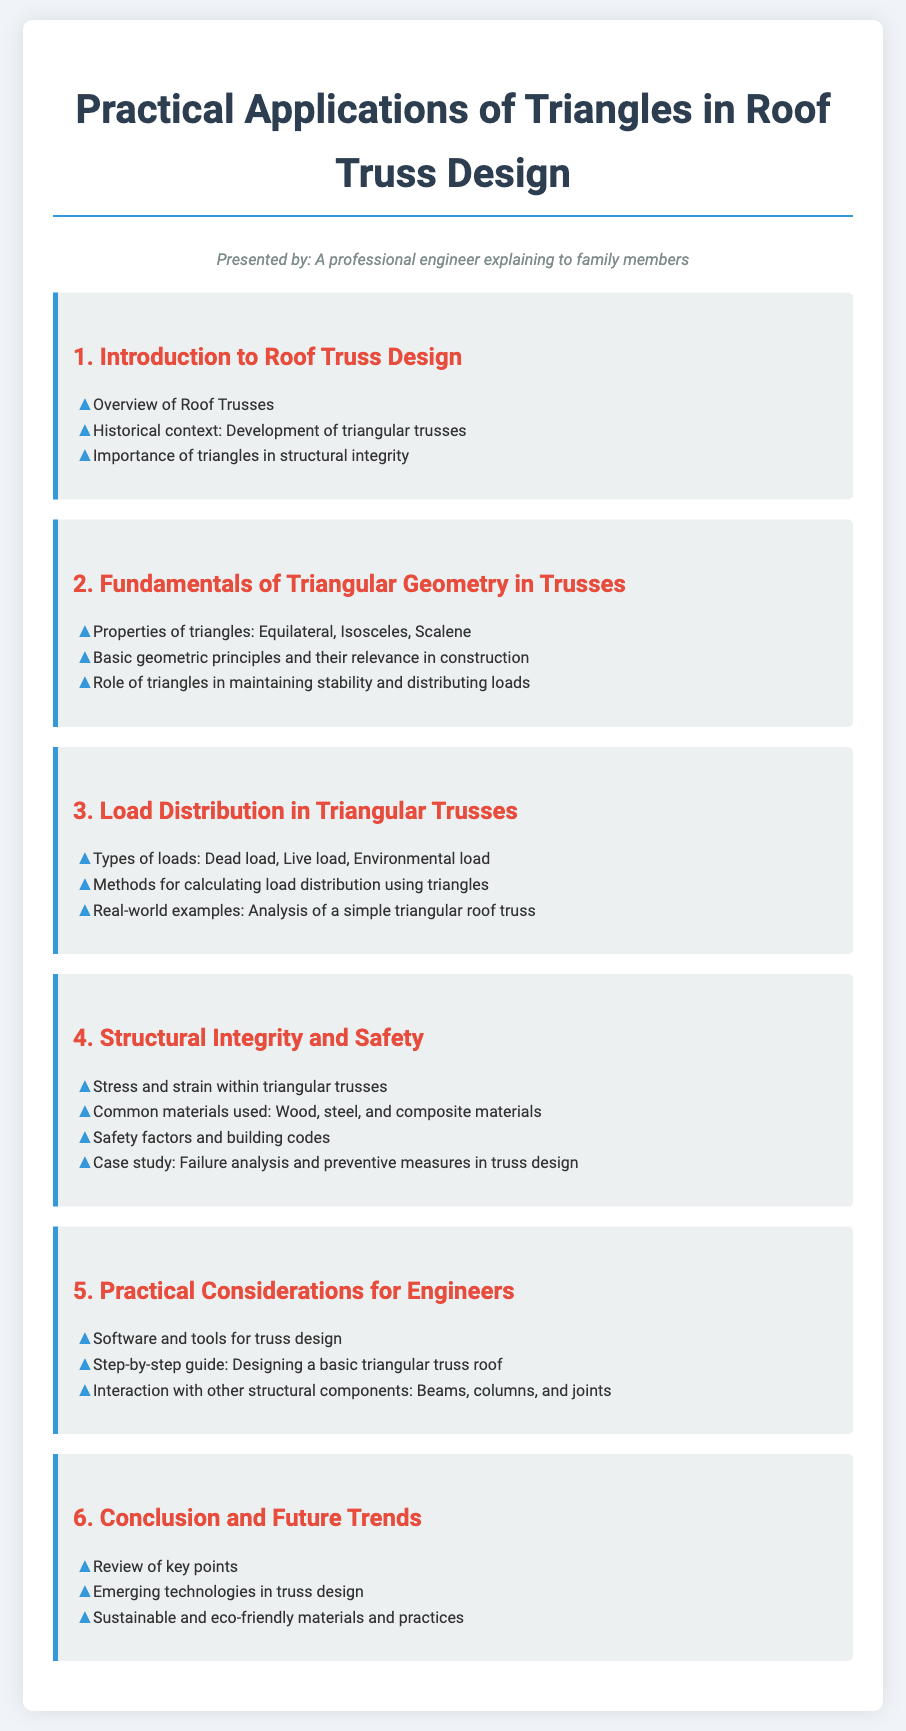What is the title of the syllabus? The title of the syllabus is presented at the top of the document, outlining the main focus of the content.
Answer: Practical Applications of Triangles in Roof Truss Design What is one type of load discussed in the syllabus? The syllabus lists various types of loads under section 3, which are critical for understanding roof truss design.
Answer: Dead load Which section covers the properties of triangles? The section numbers provide a structured way to identify the fundamental concepts related to triangular geometry in trusses.
Answer: 2 What material is commonly used in truss design? This information is specified in the fourth section where different materials are mentioned in relation to truss integrity.
Answer: Wood What is emphasized in the conclusion of the syllabus? The last section summarizes and reviews the important points made throughout the document, focusing on future developments.
Answer: Emerging technologies What is the primary focus of section 4? This section addresses key safety aspects in truss design, detailing the stresses and materials that ensure structural integrity.
Answer: Structural Integrity and Safety What kind of guide is provided in section 5? The syllabus includes practical advice for engineers engaged in truss design, offering procedural insights.
Answer: Step-by-step guide What is a common type of truss shape discussed in the syllabus? The syllabus emphasizes the significance of triangles due to their unique structural abilities, thus identifying their shapes.
Answer: Triangular 